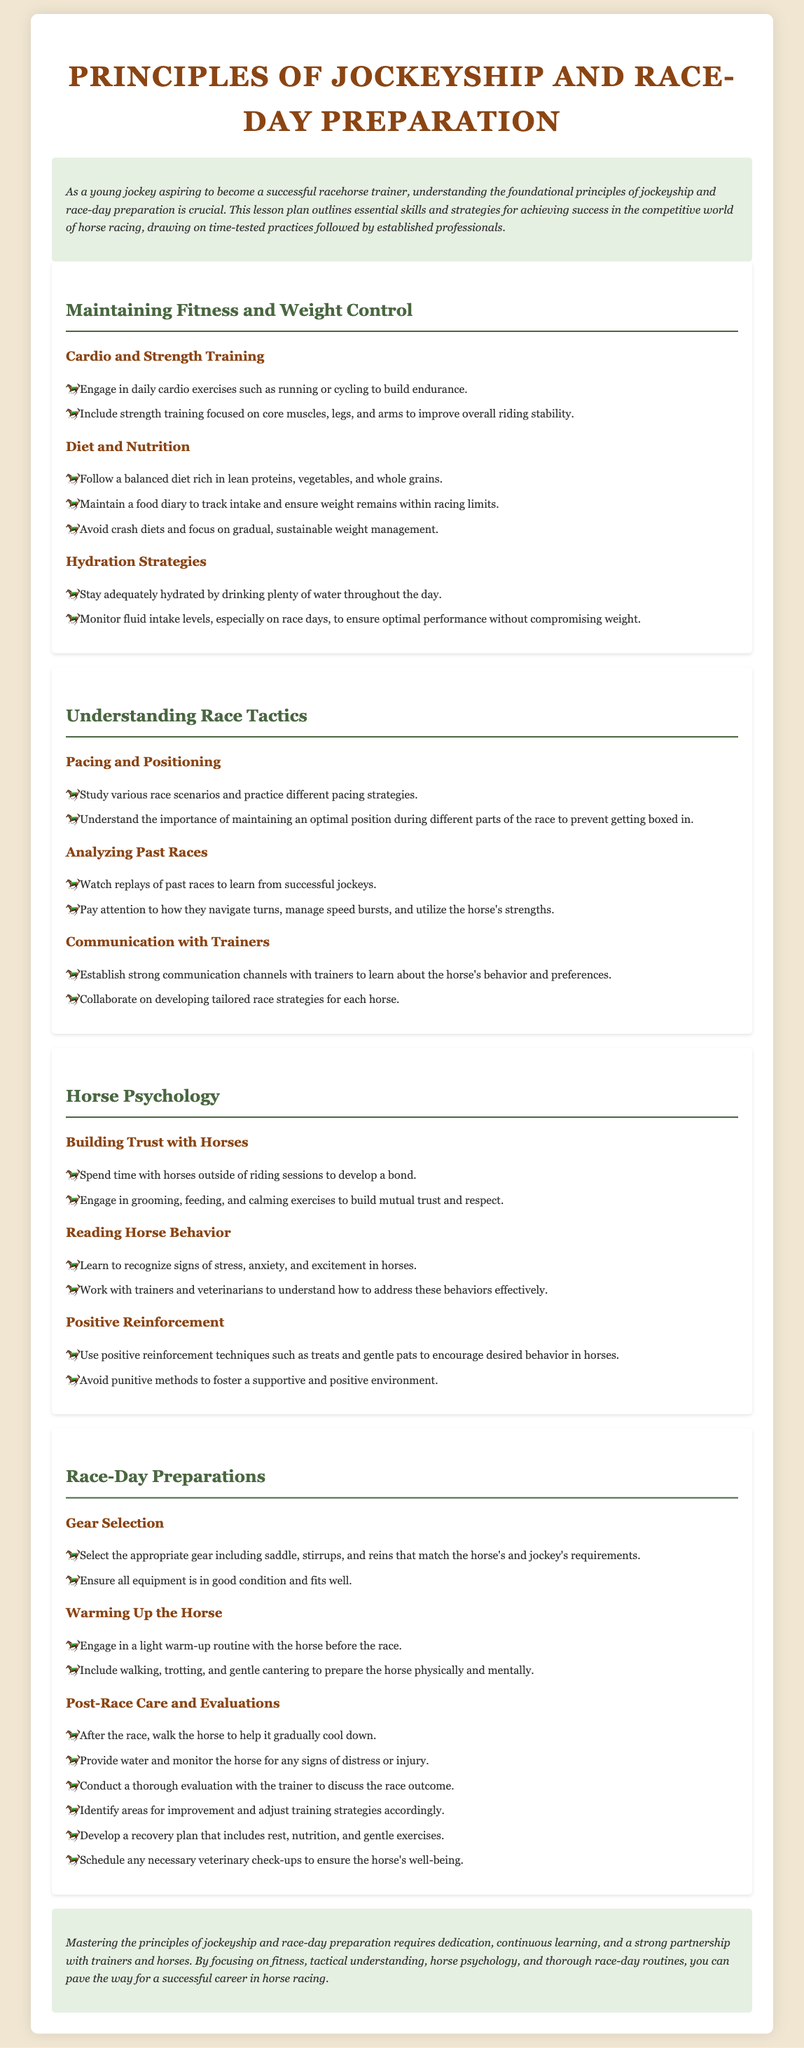what is the main focus of the lesson plan? The lesson plan outlines essential skills and strategies for aspiring jockeys and racehorse trainers in the competitive world of horse racing.
Answer: skills and strategies what type of training is recommended for maintaining fitness? The document mentions engaging in daily cardio exercises and strength training focused on core muscles, legs, and arms.
Answer: cardio and strength training what is a key component of race-day preparations regarding gear? The lesson plan emphasizes selecting the appropriate gear, including saddle, stirrups, and reins.
Answer: appropriate gear how should a jockey maintain hydration on race days? It advises monitoring fluid intake levels, especially on race days, to ensure optimal performance without compromising weight.
Answer: monitor fluid intake what is one method suggested for building trust with horses? The document recommends spending time with horses outside of riding sessions to develop a bond.
Answer: spend time with horses what is the purpose of warming up the horse? Warming up the horse includes engaging in a light warm-up routine to prepare it physically and mentally before the race.
Answer: prepare physically and mentally what technique is suggested for reinforcing desired behavior in horses? Positive reinforcement techniques such as treats and gentle pats are recommended to encourage desired behavior.
Answer: positive reinforcement techniques how many areas for improvement should be identified post-race? The document suggests conducting a thorough evaluation to discuss the race outcome and identify areas for improvement.
Answer: areas for improvement 